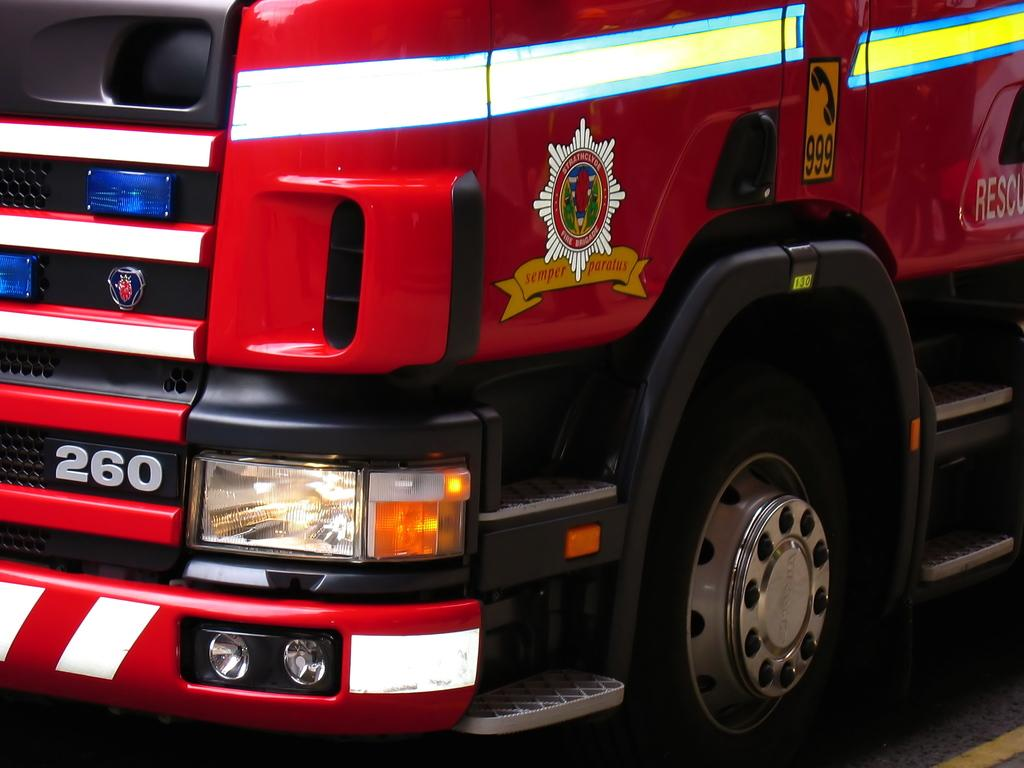What is the main subject of the image? There is a vehicle in the image. What can be seen on the vehicle? There is text and a number on the vehicle. What feature of the vehicle is visible in the image? There are lights on the vehicle. What is visible at the bottom of the image? There is a road visible at the bottom of the image. How does the vehicle contribute to society in the image? The image does not provide information about the vehicle's contribution to society; it only shows the vehicle's appearance and location. 